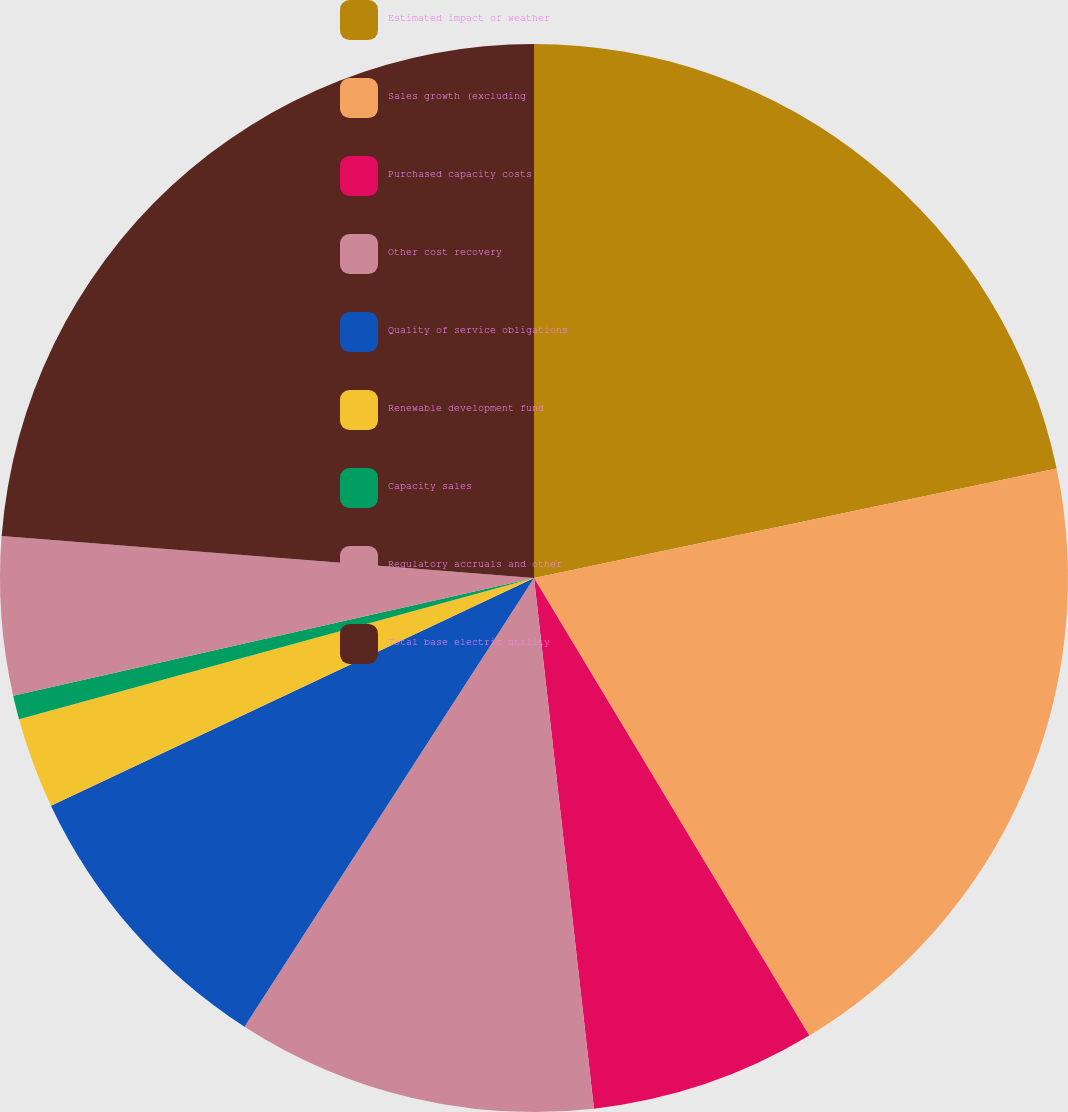Convert chart to OTSL. <chart><loc_0><loc_0><loc_500><loc_500><pie_chart><fcel>Estimated impact of weather<fcel>Sales growth (excluding<fcel>Purchased capacity costs<fcel>Other cost recovery<fcel>Quality of service obligations<fcel>Renewable development fund<fcel>Capacity sales<fcel>Regulatory accruals and other<fcel>Total base electric utility<nl><fcel>21.71%<fcel>19.67%<fcel>6.83%<fcel>10.91%<fcel>8.87%<fcel>2.75%<fcel>0.72%<fcel>4.79%<fcel>23.75%<nl></chart> 